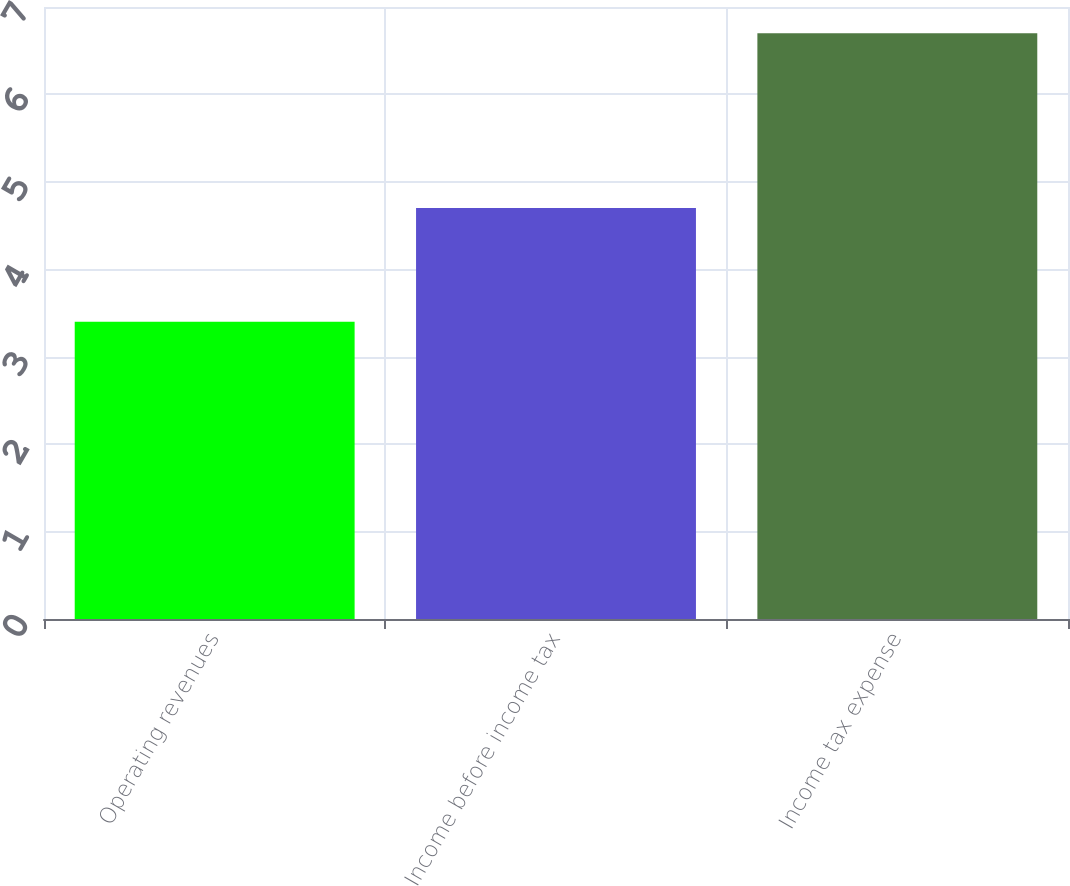Convert chart. <chart><loc_0><loc_0><loc_500><loc_500><bar_chart><fcel>Operating revenues<fcel>Income before income tax<fcel>Income tax expense<nl><fcel>3.4<fcel>4.7<fcel>6.7<nl></chart> 